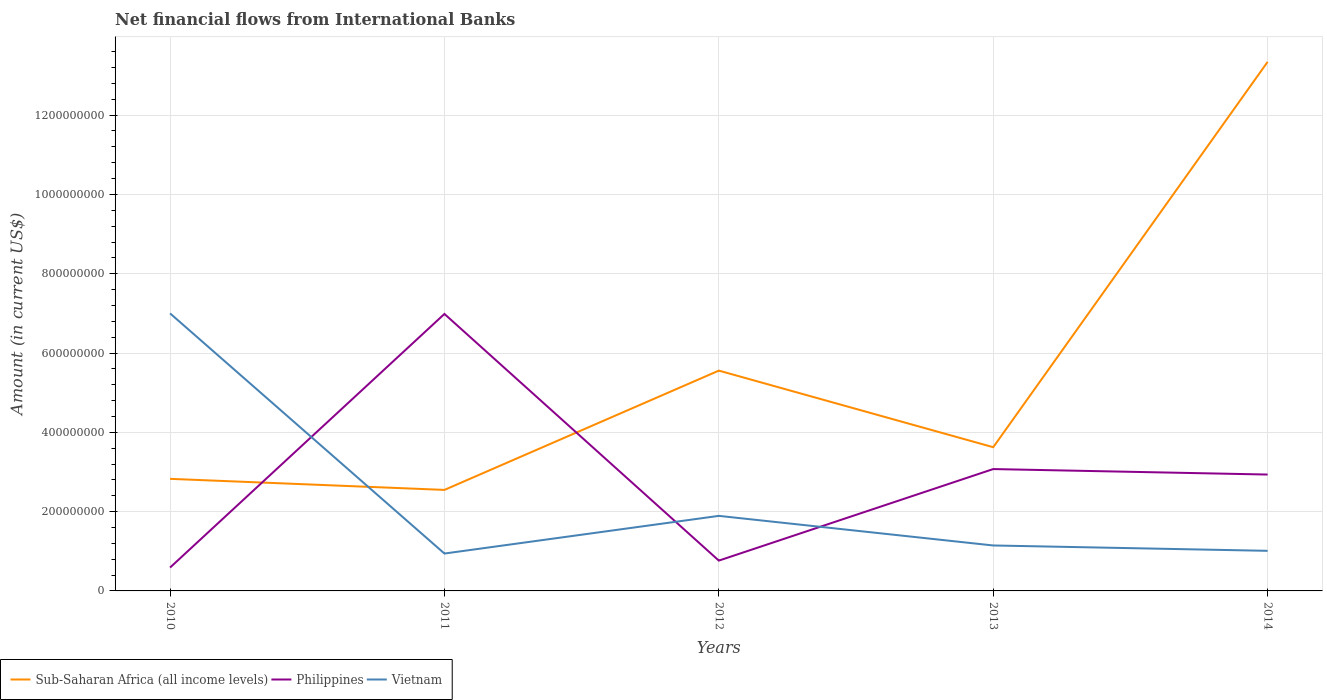Does the line corresponding to Sub-Saharan Africa (all income levels) intersect with the line corresponding to Philippines?
Give a very brief answer. Yes. Across all years, what is the maximum net financial aid flows in Sub-Saharan Africa (all income levels)?
Keep it short and to the point. 2.55e+08. What is the total net financial aid flows in Vietnam in the graph?
Provide a succinct answer. 7.47e+07. What is the difference between the highest and the second highest net financial aid flows in Vietnam?
Keep it short and to the point. 6.06e+08. What is the difference between the highest and the lowest net financial aid flows in Sub-Saharan Africa (all income levels)?
Provide a succinct answer. 1. How many lines are there?
Your answer should be very brief. 3. Does the graph contain any zero values?
Keep it short and to the point. No. Does the graph contain grids?
Give a very brief answer. Yes. Where does the legend appear in the graph?
Your answer should be very brief. Bottom left. How are the legend labels stacked?
Ensure brevity in your answer.  Horizontal. What is the title of the graph?
Offer a very short reply. Net financial flows from International Banks. What is the Amount (in current US$) of Sub-Saharan Africa (all income levels) in 2010?
Your answer should be very brief. 2.83e+08. What is the Amount (in current US$) in Philippines in 2010?
Provide a short and direct response. 5.89e+07. What is the Amount (in current US$) in Vietnam in 2010?
Give a very brief answer. 7.00e+08. What is the Amount (in current US$) in Sub-Saharan Africa (all income levels) in 2011?
Provide a short and direct response. 2.55e+08. What is the Amount (in current US$) of Philippines in 2011?
Your response must be concise. 6.99e+08. What is the Amount (in current US$) of Vietnam in 2011?
Offer a terse response. 9.43e+07. What is the Amount (in current US$) in Sub-Saharan Africa (all income levels) in 2012?
Your answer should be compact. 5.56e+08. What is the Amount (in current US$) in Philippines in 2012?
Provide a succinct answer. 7.65e+07. What is the Amount (in current US$) of Vietnam in 2012?
Ensure brevity in your answer.  1.89e+08. What is the Amount (in current US$) in Sub-Saharan Africa (all income levels) in 2013?
Make the answer very short. 3.62e+08. What is the Amount (in current US$) of Philippines in 2013?
Your response must be concise. 3.07e+08. What is the Amount (in current US$) of Vietnam in 2013?
Offer a terse response. 1.15e+08. What is the Amount (in current US$) in Sub-Saharan Africa (all income levels) in 2014?
Offer a very short reply. 1.33e+09. What is the Amount (in current US$) of Philippines in 2014?
Your answer should be very brief. 2.94e+08. What is the Amount (in current US$) of Vietnam in 2014?
Offer a terse response. 1.01e+08. Across all years, what is the maximum Amount (in current US$) in Sub-Saharan Africa (all income levels)?
Ensure brevity in your answer.  1.33e+09. Across all years, what is the maximum Amount (in current US$) of Philippines?
Your answer should be very brief. 6.99e+08. Across all years, what is the maximum Amount (in current US$) in Vietnam?
Give a very brief answer. 7.00e+08. Across all years, what is the minimum Amount (in current US$) of Sub-Saharan Africa (all income levels)?
Make the answer very short. 2.55e+08. Across all years, what is the minimum Amount (in current US$) in Philippines?
Provide a short and direct response. 5.89e+07. Across all years, what is the minimum Amount (in current US$) in Vietnam?
Your response must be concise. 9.43e+07. What is the total Amount (in current US$) in Sub-Saharan Africa (all income levels) in the graph?
Provide a short and direct response. 2.79e+09. What is the total Amount (in current US$) in Philippines in the graph?
Your response must be concise. 1.43e+09. What is the total Amount (in current US$) of Vietnam in the graph?
Your response must be concise. 1.20e+09. What is the difference between the Amount (in current US$) in Sub-Saharan Africa (all income levels) in 2010 and that in 2011?
Make the answer very short. 2.79e+07. What is the difference between the Amount (in current US$) of Philippines in 2010 and that in 2011?
Your answer should be very brief. -6.40e+08. What is the difference between the Amount (in current US$) of Vietnam in 2010 and that in 2011?
Your response must be concise. 6.06e+08. What is the difference between the Amount (in current US$) in Sub-Saharan Africa (all income levels) in 2010 and that in 2012?
Keep it short and to the point. -2.73e+08. What is the difference between the Amount (in current US$) in Philippines in 2010 and that in 2012?
Give a very brief answer. -1.75e+07. What is the difference between the Amount (in current US$) in Vietnam in 2010 and that in 2012?
Your answer should be compact. 5.11e+08. What is the difference between the Amount (in current US$) of Sub-Saharan Africa (all income levels) in 2010 and that in 2013?
Ensure brevity in your answer.  -7.98e+07. What is the difference between the Amount (in current US$) of Philippines in 2010 and that in 2013?
Give a very brief answer. -2.48e+08. What is the difference between the Amount (in current US$) of Vietnam in 2010 and that in 2013?
Give a very brief answer. 5.85e+08. What is the difference between the Amount (in current US$) in Sub-Saharan Africa (all income levels) in 2010 and that in 2014?
Your answer should be compact. -1.05e+09. What is the difference between the Amount (in current US$) of Philippines in 2010 and that in 2014?
Provide a succinct answer. -2.35e+08. What is the difference between the Amount (in current US$) of Vietnam in 2010 and that in 2014?
Ensure brevity in your answer.  5.99e+08. What is the difference between the Amount (in current US$) in Sub-Saharan Africa (all income levels) in 2011 and that in 2012?
Offer a terse response. -3.01e+08. What is the difference between the Amount (in current US$) in Philippines in 2011 and that in 2012?
Provide a short and direct response. 6.22e+08. What is the difference between the Amount (in current US$) in Vietnam in 2011 and that in 2012?
Make the answer very short. -9.50e+07. What is the difference between the Amount (in current US$) of Sub-Saharan Africa (all income levels) in 2011 and that in 2013?
Keep it short and to the point. -1.08e+08. What is the difference between the Amount (in current US$) in Philippines in 2011 and that in 2013?
Keep it short and to the point. 3.91e+08. What is the difference between the Amount (in current US$) of Vietnam in 2011 and that in 2013?
Provide a short and direct response. -2.03e+07. What is the difference between the Amount (in current US$) in Sub-Saharan Africa (all income levels) in 2011 and that in 2014?
Keep it short and to the point. -1.08e+09. What is the difference between the Amount (in current US$) of Philippines in 2011 and that in 2014?
Offer a terse response. 4.05e+08. What is the difference between the Amount (in current US$) in Vietnam in 2011 and that in 2014?
Ensure brevity in your answer.  -6.83e+06. What is the difference between the Amount (in current US$) in Sub-Saharan Africa (all income levels) in 2012 and that in 2013?
Ensure brevity in your answer.  1.93e+08. What is the difference between the Amount (in current US$) of Philippines in 2012 and that in 2013?
Give a very brief answer. -2.31e+08. What is the difference between the Amount (in current US$) of Vietnam in 2012 and that in 2013?
Provide a succinct answer. 7.47e+07. What is the difference between the Amount (in current US$) in Sub-Saharan Africa (all income levels) in 2012 and that in 2014?
Keep it short and to the point. -7.79e+08. What is the difference between the Amount (in current US$) in Philippines in 2012 and that in 2014?
Keep it short and to the point. -2.17e+08. What is the difference between the Amount (in current US$) of Vietnam in 2012 and that in 2014?
Offer a terse response. 8.82e+07. What is the difference between the Amount (in current US$) of Sub-Saharan Africa (all income levels) in 2013 and that in 2014?
Offer a terse response. -9.72e+08. What is the difference between the Amount (in current US$) of Philippines in 2013 and that in 2014?
Offer a very short reply. 1.38e+07. What is the difference between the Amount (in current US$) of Vietnam in 2013 and that in 2014?
Your answer should be very brief. 1.35e+07. What is the difference between the Amount (in current US$) of Sub-Saharan Africa (all income levels) in 2010 and the Amount (in current US$) of Philippines in 2011?
Give a very brief answer. -4.16e+08. What is the difference between the Amount (in current US$) in Sub-Saharan Africa (all income levels) in 2010 and the Amount (in current US$) in Vietnam in 2011?
Make the answer very short. 1.88e+08. What is the difference between the Amount (in current US$) of Philippines in 2010 and the Amount (in current US$) of Vietnam in 2011?
Ensure brevity in your answer.  -3.54e+07. What is the difference between the Amount (in current US$) of Sub-Saharan Africa (all income levels) in 2010 and the Amount (in current US$) of Philippines in 2012?
Give a very brief answer. 2.06e+08. What is the difference between the Amount (in current US$) in Sub-Saharan Africa (all income levels) in 2010 and the Amount (in current US$) in Vietnam in 2012?
Offer a very short reply. 9.34e+07. What is the difference between the Amount (in current US$) of Philippines in 2010 and the Amount (in current US$) of Vietnam in 2012?
Keep it short and to the point. -1.30e+08. What is the difference between the Amount (in current US$) in Sub-Saharan Africa (all income levels) in 2010 and the Amount (in current US$) in Philippines in 2013?
Provide a short and direct response. -2.47e+07. What is the difference between the Amount (in current US$) of Sub-Saharan Africa (all income levels) in 2010 and the Amount (in current US$) of Vietnam in 2013?
Your answer should be very brief. 1.68e+08. What is the difference between the Amount (in current US$) in Philippines in 2010 and the Amount (in current US$) in Vietnam in 2013?
Offer a very short reply. -5.57e+07. What is the difference between the Amount (in current US$) in Sub-Saharan Africa (all income levels) in 2010 and the Amount (in current US$) in Philippines in 2014?
Give a very brief answer. -1.08e+07. What is the difference between the Amount (in current US$) in Sub-Saharan Africa (all income levels) in 2010 and the Amount (in current US$) in Vietnam in 2014?
Provide a succinct answer. 1.82e+08. What is the difference between the Amount (in current US$) of Philippines in 2010 and the Amount (in current US$) of Vietnam in 2014?
Make the answer very short. -4.22e+07. What is the difference between the Amount (in current US$) in Sub-Saharan Africa (all income levels) in 2011 and the Amount (in current US$) in Philippines in 2012?
Provide a succinct answer. 1.78e+08. What is the difference between the Amount (in current US$) of Sub-Saharan Africa (all income levels) in 2011 and the Amount (in current US$) of Vietnam in 2012?
Ensure brevity in your answer.  6.55e+07. What is the difference between the Amount (in current US$) of Philippines in 2011 and the Amount (in current US$) of Vietnam in 2012?
Your response must be concise. 5.09e+08. What is the difference between the Amount (in current US$) of Sub-Saharan Africa (all income levels) in 2011 and the Amount (in current US$) of Philippines in 2013?
Offer a very short reply. -5.26e+07. What is the difference between the Amount (in current US$) in Sub-Saharan Africa (all income levels) in 2011 and the Amount (in current US$) in Vietnam in 2013?
Your answer should be compact. 1.40e+08. What is the difference between the Amount (in current US$) of Philippines in 2011 and the Amount (in current US$) of Vietnam in 2013?
Provide a short and direct response. 5.84e+08. What is the difference between the Amount (in current US$) of Sub-Saharan Africa (all income levels) in 2011 and the Amount (in current US$) of Philippines in 2014?
Your answer should be compact. -3.88e+07. What is the difference between the Amount (in current US$) of Sub-Saharan Africa (all income levels) in 2011 and the Amount (in current US$) of Vietnam in 2014?
Your response must be concise. 1.54e+08. What is the difference between the Amount (in current US$) of Philippines in 2011 and the Amount (in current US$) of Vietnam in 2014?
Offer a very short reply. 5.97e+08. What is the difference between the Amount (in current US$) in Sub-Saharan Africa (all income levels) in 2012 and the Amount (in current US$) in Philippines in 2013?
Your answer should be very brief. 2.48e+08. What is the difference between the Amount (in current US$) in Sub-Saharan Africa (all income levels) in 2012 and the Amount (in current US$) in Vietnam in 2013?
Offer a terse response. 4.41e+08. What is the difference between the Amount (in current US$) of Philippines in 2012 and the Amount (in current US$) of Vietnam in 2013?
Provide a succinct answer. -3.82e+07. What is the difference between the Amount (in current US$) of Sub-Saharan Africa (all income levels) in 2012 and the Amount (in current US$) of Philippines in 2014?
Offer a very short reply. 2.62e+08. What is the difference between the Amount (in current US$) in Sub-Saharan Africa (all income levels) in 2012 and the Amount (in current US$) in Vietnam in 2014?
Keep it short and to the point. 4.55e+08. What is the difference between the Amount (in current US$) of Philippines in 2012 and the Amount (in current US$) of Vietnam in 2014?
Keep it short and to the point. -2.46e+07. What is the difference between the Amount (in current US$) of Sub-Saharan Africa (all income levels) in 2013 and the Amount (in current US$) of Philippines in 2014?
Offer a very short reply. 6.89e+07. What is the difference between the Amount (in current US$) in Sub-Saharan Africa (all income levels) in 2013 and the Amount (in current US$) in Vietnam in 2014?
Your answer should be compact. 2.61e+08. What is the difference between the Amount (in current US$) of Philippines in 2013 and the Amount (in current US$) of Vietnam in 2014?
Provide a short and direct response. 2.06e+08. What is the average Amount (in current US$) of Sub-Saharan Africa (all income levels) per year?
Ensure brevity in your answer.  5.58e+08. What is the average Amount (in current US$) of Philippines per year?
Offer a terse response. 2.87e+08. What is the average Amount (in current US$) of Vietnam per year?
Keep it short and to the point. 2.40e+08. In the year 2010, what is the difference between the Amount (in current US$) in Sub-Saharan Africa (all income levels) and Amount (in current US$) in Philippines?
Your response must be concise. 2.24e+08. In the year 2010, what is the difference between the Amount (in current US$) in Sub-Saharan Africa (all income levels) and Amount (in current US$) in Vietnam?
Offer a very short reply. -4.17e+08. In the year 2010, what is the difference between the Amount (in current US$) of Philippines and Amount (in current US$) of Vietnam?
Your response must be concise. -6.41e+08. In the year 2011, what is the difference between the Amount (in current US$) in Sub-Saharan Africa (all income levels) and Amount (in current US$) in Philippines?
Provide a succinct answer. -4.44e+08. In the year 2011, what is the difference between the Amount (in current US$) in Sub-Saharan Africa (all income levels) and Amount (in current US$) in Vietnam?
Keep it short and to the point. 1.60e+08. In the year 2011, what is the difference between the Amount (in current US$) in Philippines and Amount (in current US$) in Vietnam?
Provide a short and direct response. 6.04e+08. In the year 2012, what is the difference between the Amount (in current US$) of Sub-Saharan Africa (all income levels) and Amount (in current US$) of Philippines?
Keep it short and to the point. 4.79e+08. In the year 2012, what is the difference between the Amount (in current US$) in Sub-Saharan Africa (all income levels) and Amount (in current US$) in Vietnam?
Give a very brief answer. 3.66e+08. In the year 2012, what is the difference between the Amount (in current US$) in Philippines and Amount (in current US$) in Vietnam?
Make the answer very short. -1.13e+08. In the year 2013, what is the difference between the Amount (in current US$) in Sub-Saharan Africa (all income levels) and Amount (in current US$) in Philippines?
Offer a very short reply. 5.51e+07. In the year 2013, what is the difference between the Amount (in current US$) of Sub-Saharan Africa (all income levels) and Amount (in current US$) of Vietnam?
Make the answer very short. 2.48e+08. In the year 2013, what is the difference between the Amount (in current US$) of Philippines and Amount (in current US$) of Vietnam?
Offer a very short reply. 1.93e+08. In the year 2014, what is the difference between the Amount (in current US$) of Sub-Saharan Africa (all income levels) and Amount (in current US$) of Philippines?
Your answer should be very brief. 1.04e+09. In the year 2014, what is the difference between the Amount (in current US$) of Sub-Saharan Africa (all income levels) and Amount (in current US$) of Vietnam?
Keep it short and to the point. 1.23e+09. In the year 2014, what is the difference between the Amount (in current US$) in Philippines and Amount (in current US$) in Vietnam?
Your answer should be very brief. 1.92e+08. What is the ratio of the Amount (in current US$) in Sub-Saharan Africa (all income levels) in 2010 to that in 2011?
Make the answer very short. 1.11. What is the ratio of the Amount (in current US$) of Philippines in 2010 to that in 2011?
Make the answer very short. 0.08. What is the ratio of the Amount (in current US$) in Vietnam in 2010 to that in 2011?
Your answer should be very brief. 7.42. What is the ratio of the Amount (in current US$) of Sub-Saharan Africa (all income levels) in 2010 to that in 2012?
Your answer should be compact. 0.51. What is the ratio of the Amount (in current US$) in Philippines in 2010 to that in 2012?
Give a very brief answer. 0.77. What is the ratio of the Amount (in current US$) in Vietnam in 2010 to that in 2012?
Keep it short and to the point. 3.7. What is the ratio of the Amount (in current US$) in Sub-Saharan Africa (all income levels) in 2010 to that in 2013?
Your response must be concise. 0.78. What is the ratio of the Amount (in current US$) of Philippines in 2010 to that in 2013?
Your answer should be compact. 0.19. What is the ratio of the Amount (in current US$) in Vietnam in 2010 to that in 2013?
Make the answer very short. 6.11. What is the ratio of the Amount (in current US$) of Sub-Saharan Africa (all income levels) in 2010 to that in 2014?
Keep it short and to the point. 0.21. What is the ratio of the Amount (in current US$) of Philippines in 2010 to that in 2014?
Provide a short and direct response. 0.2. What is the ratio of the Amount (in current US$) in Vietnam in 2010 to that in 2014?
Provide a succinct answer. 6.92. What is the ratio of the Amount (in current US$) of Sub-Saharan Africa (all income levels) in 2011 to that in 2012?
Your answer should be very brief. 0.46. What is the ratio of the Amount (in current US$) in Philippines in 2011 to that in 2012?
Your response must be concise. 9.13. What is the ratio of the Amount (in current US$) in Vietnam in 2011 to that in 2012?
Give a very brief answer. 0.5. What is the ratio of the Amount (in current US$) of Sub-Saharan Africa (all income levels) in 2011 to that in 2013?
Your response must be concise. 0.7. What is the ratio of the Amount (in current US$) in Philippines in 2011 to that in 2013?
Offer a very short reply. 2.27. What is the ratio of the Amount (in current US$) of Vietnam in 2011 to that in 2013?
Provide a short and direct response. 0.82. What is the ratio of the Amount (in current US$) in Sub-Saharan Africa (all income levels) in 2011 to that in 2014?
Provide a succinct answer. 0.19. What is the ratio of the Amount (in current US$) of Philippines in 2011 to that in 2014?
Offer a very short reply. 2.38. What is the ratio of the Amount (in current US$) in Vietnam in 2011 to that in 2014?
Keep it short and to the point. 0.93. What is the ratio of the Amount (in current US$) in Sub-Saharan Africa (all income levels) in 2012 to that in 2013?
Ensure brevity in your answer.  1.53. What is the ratio of the Amount (in current US$) of Philippines in 2012 to that in 2013?
Your response must be concise. 0.25. What is the ratio of the Amount (in current US$) in Vietnam in 2012 to that in 2013?
Your response must be concise. 1.65. What is the ratio of the Amount (in current US$) in Sub-Saharan Africa (all income levels) in 2012 to that in 2014?
Your answer should be very brief. 0.42. What is the ratio of the Amount (in current US$) of Philippines in 2012 to that in 2014?
Keep it short and to the point. 0.26. What is the ratio of the Amount (in current US$) in Vietnam in 2012 to that in 2014?
Make the answer very short. 1.87. What is the ratio of the Amount (in current US$) in Sub-Saharan Africa (all income levels) in 2013 to that in 2014?
Offer a terse response. 0.27. What is the ratio of the Amount (in current US$) of Philippines in 2013 to that in 2014?
Your answer should be very brief. 1.05. What is the ratio of the Amount (in current US$) of Vietnam in 2013 to that in 2014?
Provide a succinct answer. 1.13. What is the difference between the highest and the second highest Amount (in current US$) in Sub-Saharan Africa (all income levels)?
Keep it short and to the point. 7.79e+08. What is the difference between the highest and the second highest Amount (in current US$) in Philippines?
Provide a short and direct response. 3.91e+08. What is the difference between the highest and the second highest Amount (in current US$) in Vietnam?
Make the answer very short. 5.11e+08. What is the difference between the highest and the lowest Amount (in current US$) in Sub-Saharan Africa (all income levels)?
Give a very brief answer. 1.08e+09. What is the difference between the highest and the lowest Amount (in current US$) of Philippines?
Offer a terse response. 6.40e+08. What is the difference between the highest and the lowest Amount (in current US$) of Vietnam?
Make the answer very short. 6.06e+08. 